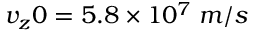Convert formula to latex. <formula><loc_0><loc_0><loc_500><loc_500>v _ { z } 0 = 5 . 8 \times 1 0 ^ { 7 } \, m / s</formula> 